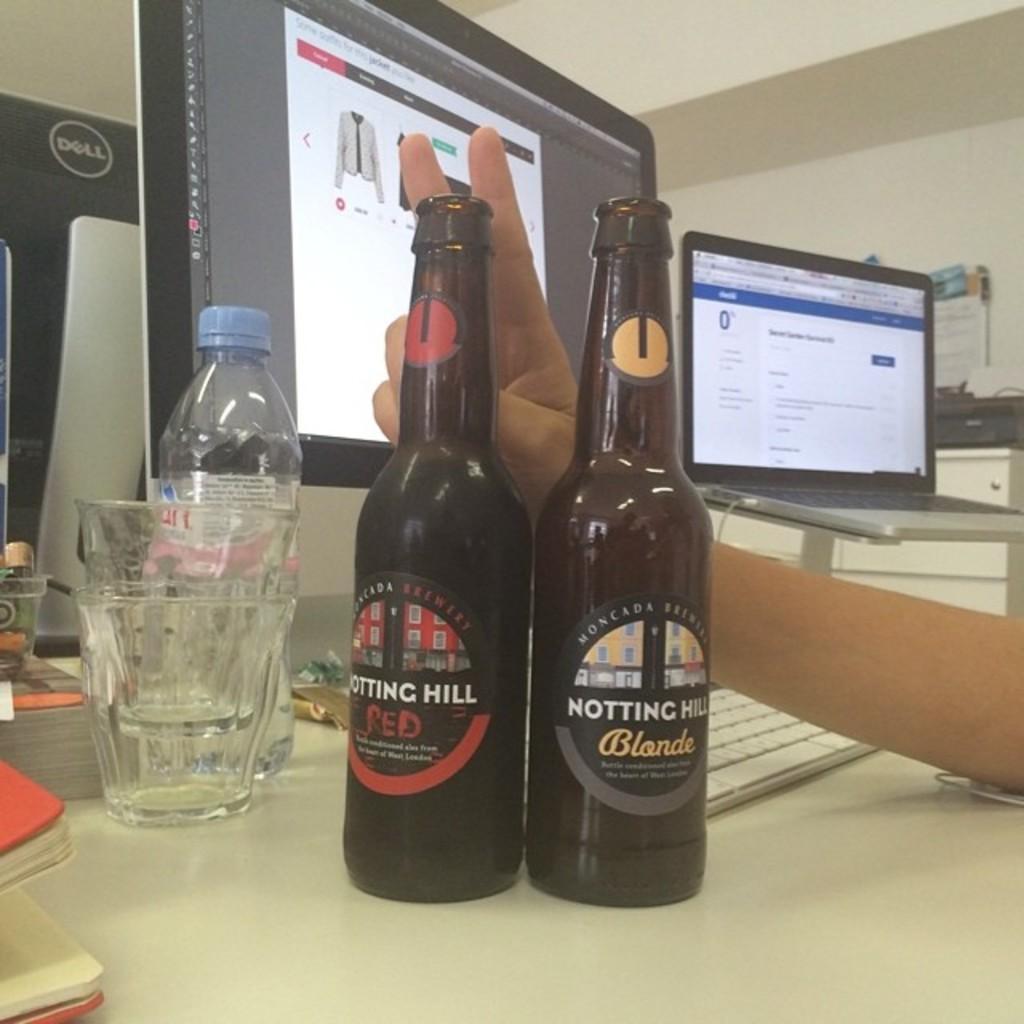Could you give a brief overview of what you see in this image? On the desk there are two wine bottles,two glasses, one water bottle and two monitors. To the right, there is a laptop and to the bottom right there is a human hand. 